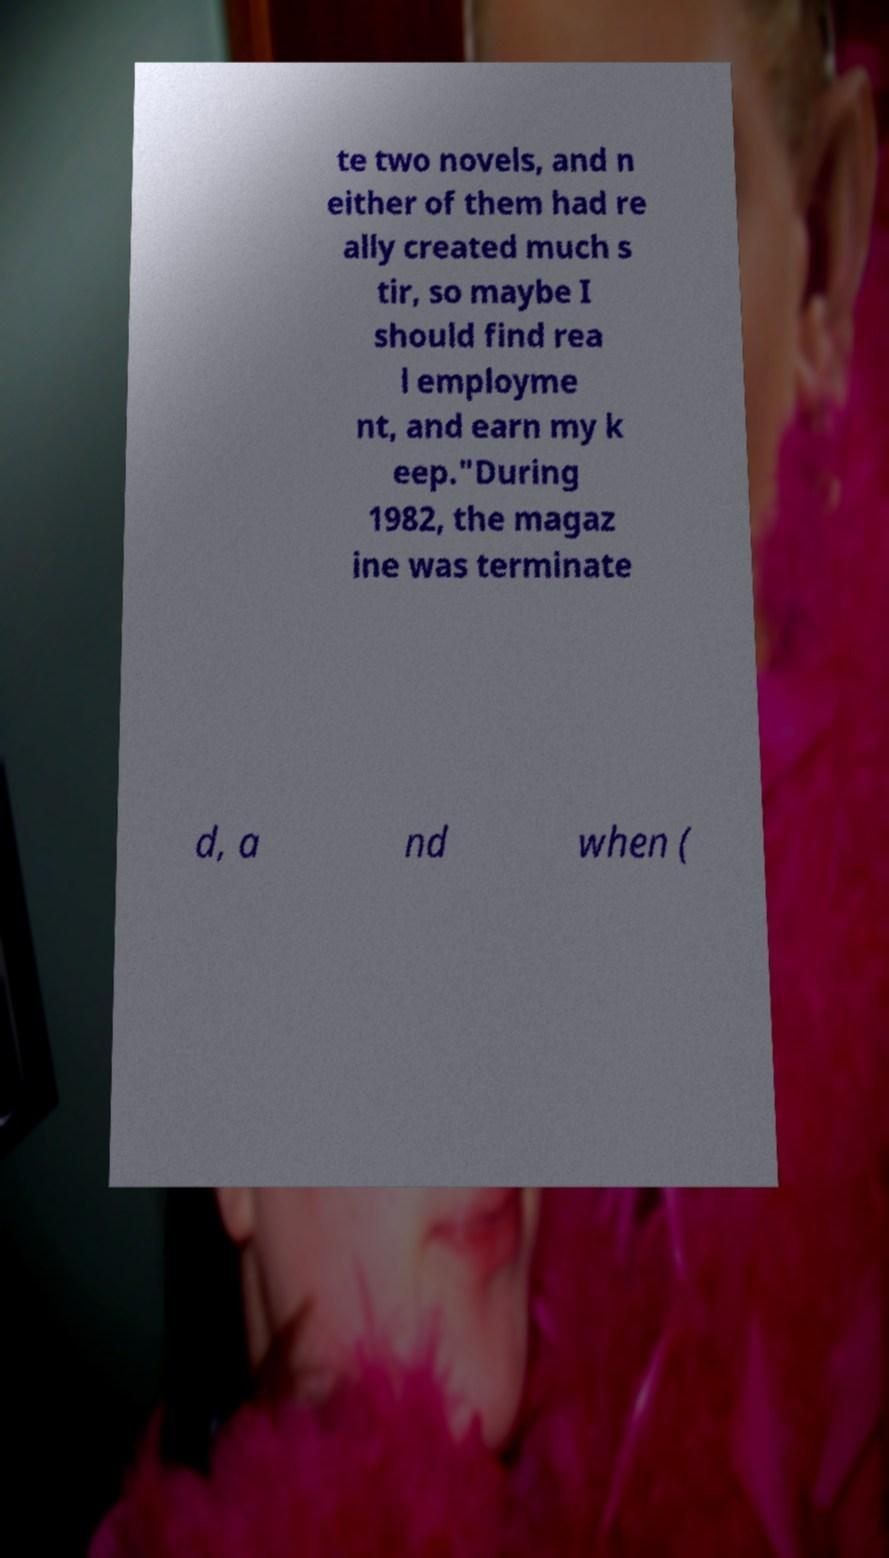I need the written content from this picture converted into text. Can you do that? te two novels, and n either of them had re ally created much s tir, so maybe I should find rea l employme nt, and earn my k eep."During 1982, the magaz ine was terminate d, a nd when ( 